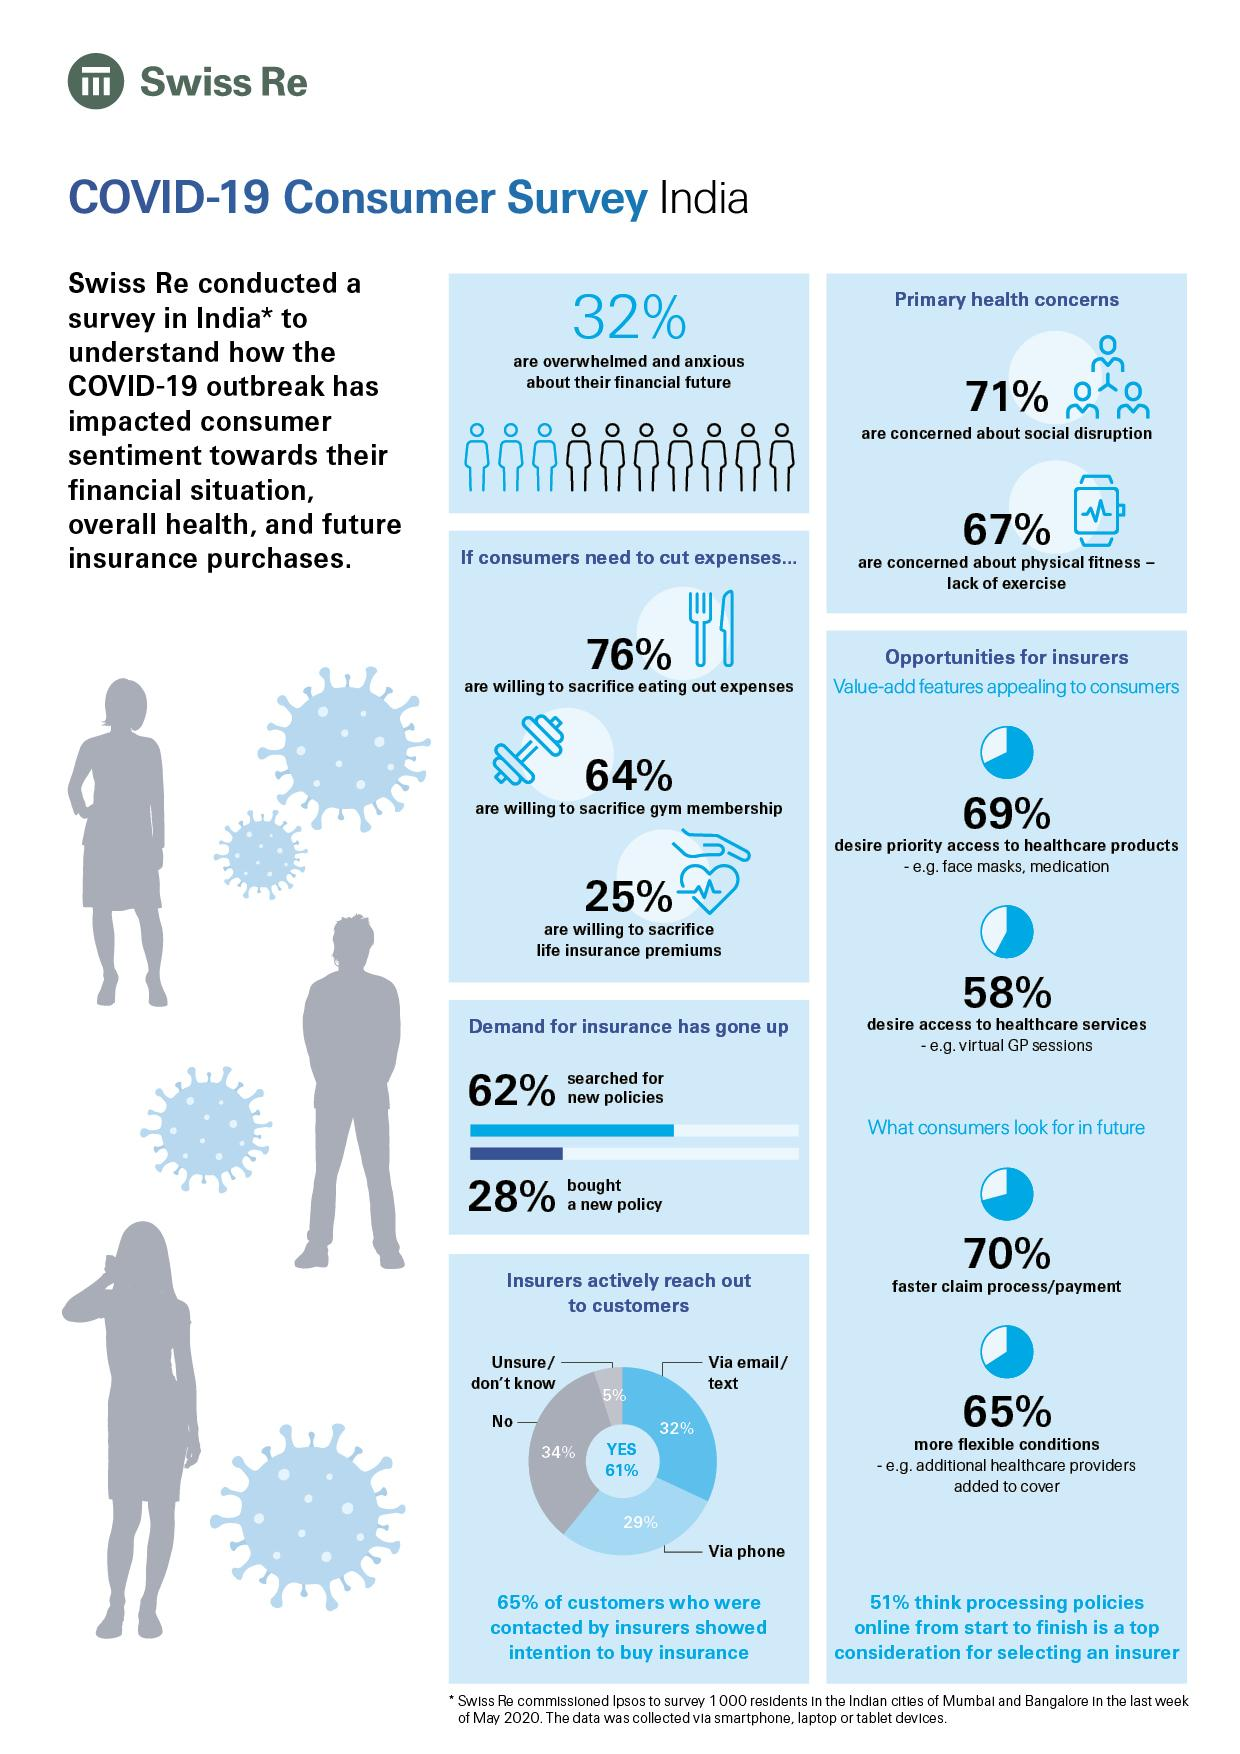Indicate a few pertinent items in this graphic. A survey found that 75% of people are not willing to sacrifice life insurance premiums. According to the survey, 24% of people are unwilling to sacrifice their eating out expenses. According to the data, 29% of people are not concerned about social disruption. According to a recent survey, 33% of people are not concerned about their physical fitness. According to the survey, 65% of consumers prefer more flexible conditions when shopping. 